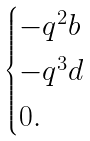<formula> <loc_0><loc_0><loc_500><loc_500>\begin{cases} - q ^ { 2 } b \\ - q ^ { 3 } d \\ 0 . \end{cases}</formula> 